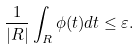<formula> <loc_0><loc_0><loc_500><loc_500>\frac { 1 } { | R | } \int _ { R } \phi ( t ) d t \leq \varepsilon .</formula> 